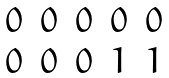Convert formula to latex. <formula><loc_0><loc_0><loc_500><loc_500>\begin{matrix} 0 & 0 & 0 & 0 & 0 \\ 0 & 0 & 0 & 1 & 1 \end{matrix}</formula> 